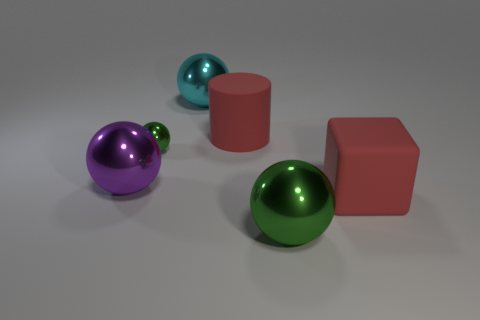There is a big metallic object that is behind the big green metal object and on the right side of the purple thing; what shape is it? The object mentioned is spherical in shape. It displays a metallic sheen, suggesting it is made of a material like polished metal, and its rounded contours catch the light, creating highlights and reflections that emphasize its curved surface. 